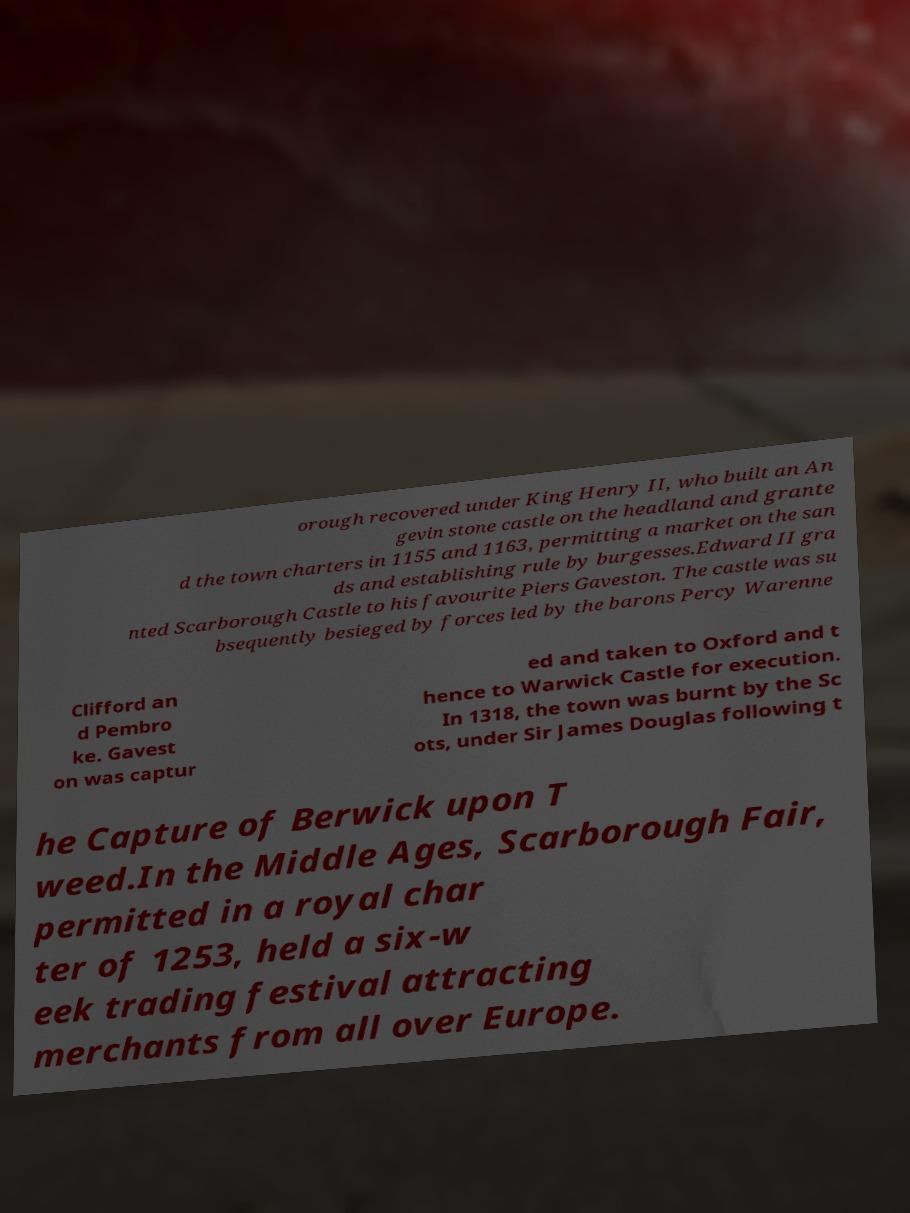Can you accurately transcribe the text from the provided image for me? orough recovered under King Henry II, who built an An gevin stone castle on the headland and grante d the town charters in 1155 and 1163, permitting a market on the san ds and establishing rule by burgesses.Edward II gra nted Scarborough Castle to his favourite Piers Gaveston. The castle was su bsequently besieged by forces led by the barons Percy Warenne Clifford an d Pembro ke. Gavest on was captur ed and taken to Oxford and t hence to Warwick Castle for execution. In 1318, the town was burnt by the Sc ots, under Sir James Douglas following t he Capture of Berwick upon T weed.In the Middle Ages, Scarborough Fair, permitted in a royal char ter of 1253, held a six-w eek trading festival attracting merchants from all over Europe. 